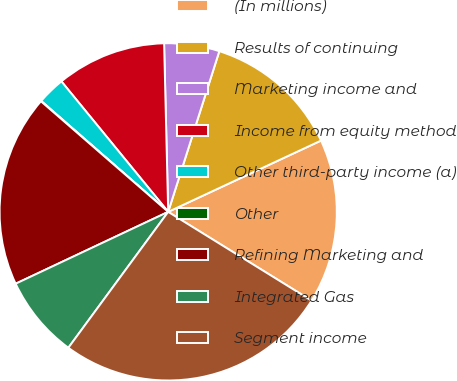Convert chart to OTSL. <chart><loc_0><loc_0><loc_500><loc_500><pie_chart><fcel>(In millions)<fcel>Results of continuing<fcel>Marketing income and<fcel>Income from equity method<fcel>Other third-party income (a)<fcel>Other<fcel>Refining Marketing and<fcel>Integrated Gas<fcel>Segment income<nl><fcel>15.77%<fcel>13.15%<fcel>5.29%<fcel>10.53%<fcel>2.66%<fcel>0.04%<fcel>18.39%<fcel>7.91%<fcel>26.26%<nl></chart> 